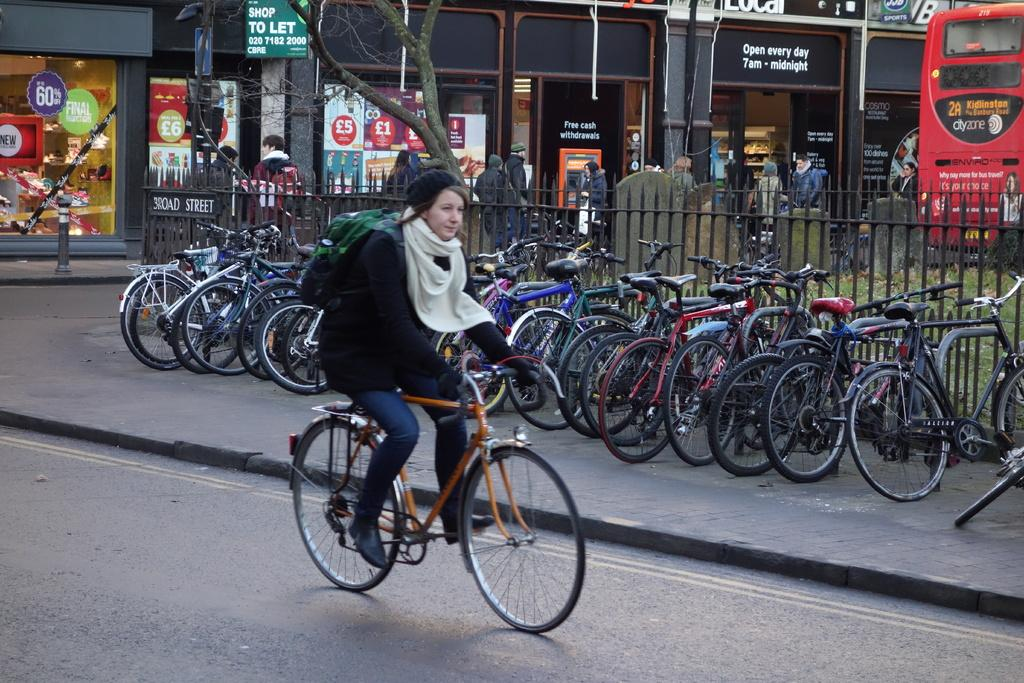Who is the main subject in the image? There is a woman in the image. What is the woman doing in the image? The woman is sitting on a bicycle. What else can be seen in the image besides the woman? There are parked bicycles on the footpath and people standing on the road. What type of root can be seen growing near the harbor in the image? There is no harbor or root present in the image. 